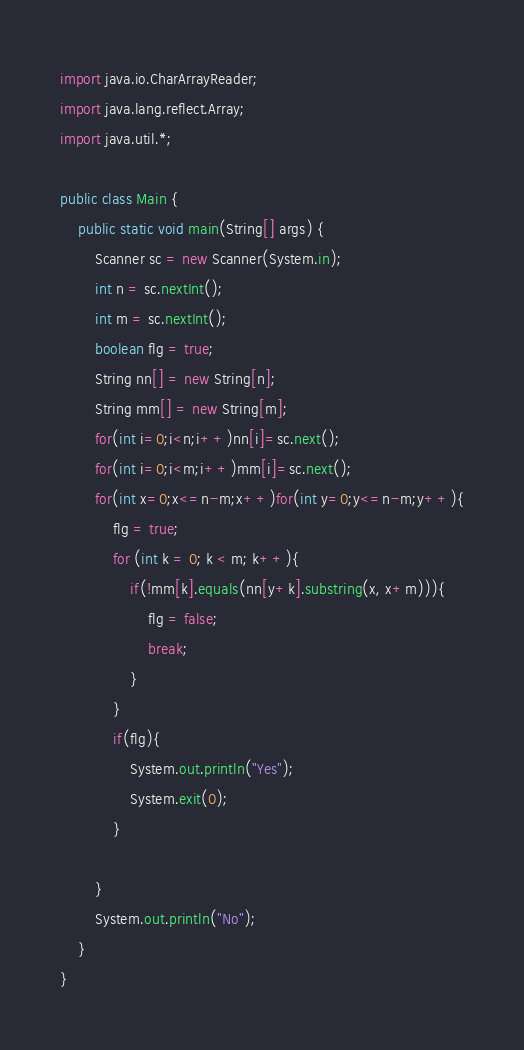<code> <loc_0><loc_0><loc_500><loc_500><_Java_>import java.io.CharArrayReader;
import java.lang.reflect.Array;
import java.util.*;

public class Main {
    public static void main(String[] args) {
        Scanner sc = new Scanner(System.in);
        int n = sc.nextInt();
        int m = sc.nextInt();
        boolean flg = true;
        String nn[] = new String[n];
        String mm[] = new String[m];
        for(int i=0;i<n;i++)nn[i]=sc.next();
        for(int i=0;i<m;i++)mm[i]=sc.next();
        for(int x=0;x<=n-m;x++)for(int y=0;y<=n-m;y++){
            flg = true;
            for (int k = 0; k < m; k++){
                if(!mm[k].equals(nn[y+k].substring(x, x+m))){
                    flg = false;
                    break;
                }
            }
            if(flg){
                System.out.println("Yes");
                System.exit(0);
            }

        }
        System.out.println("No");
    }
}
</code> 